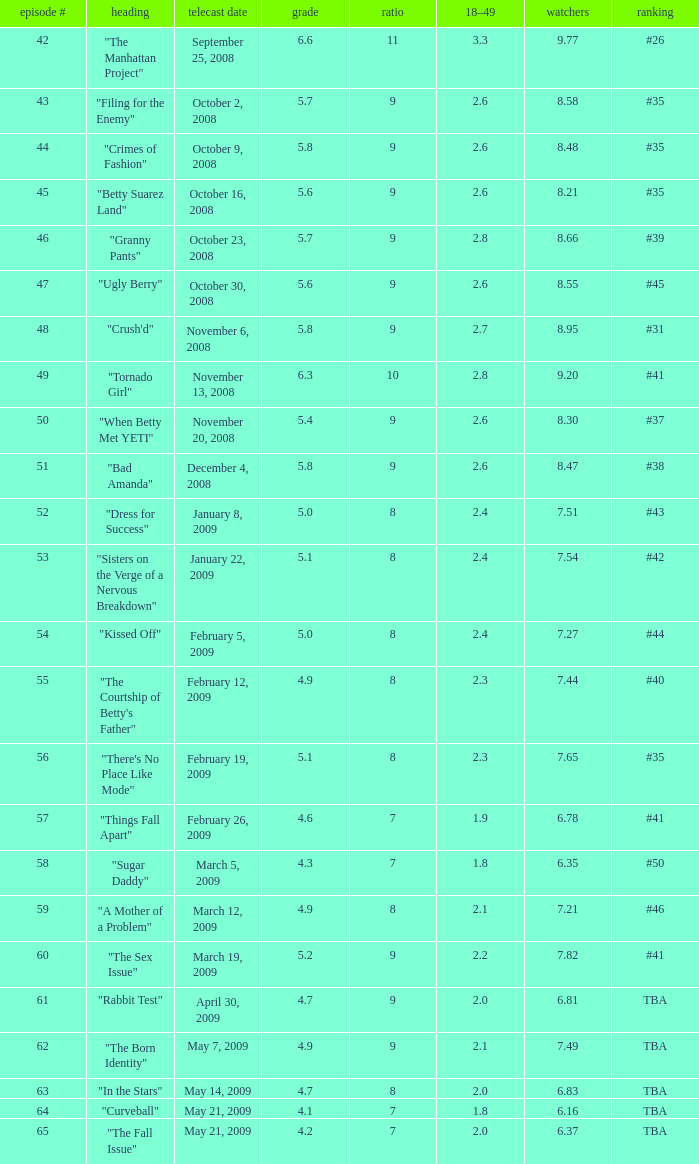What is the total number of Viewers when the rank is #40? 1.0. 